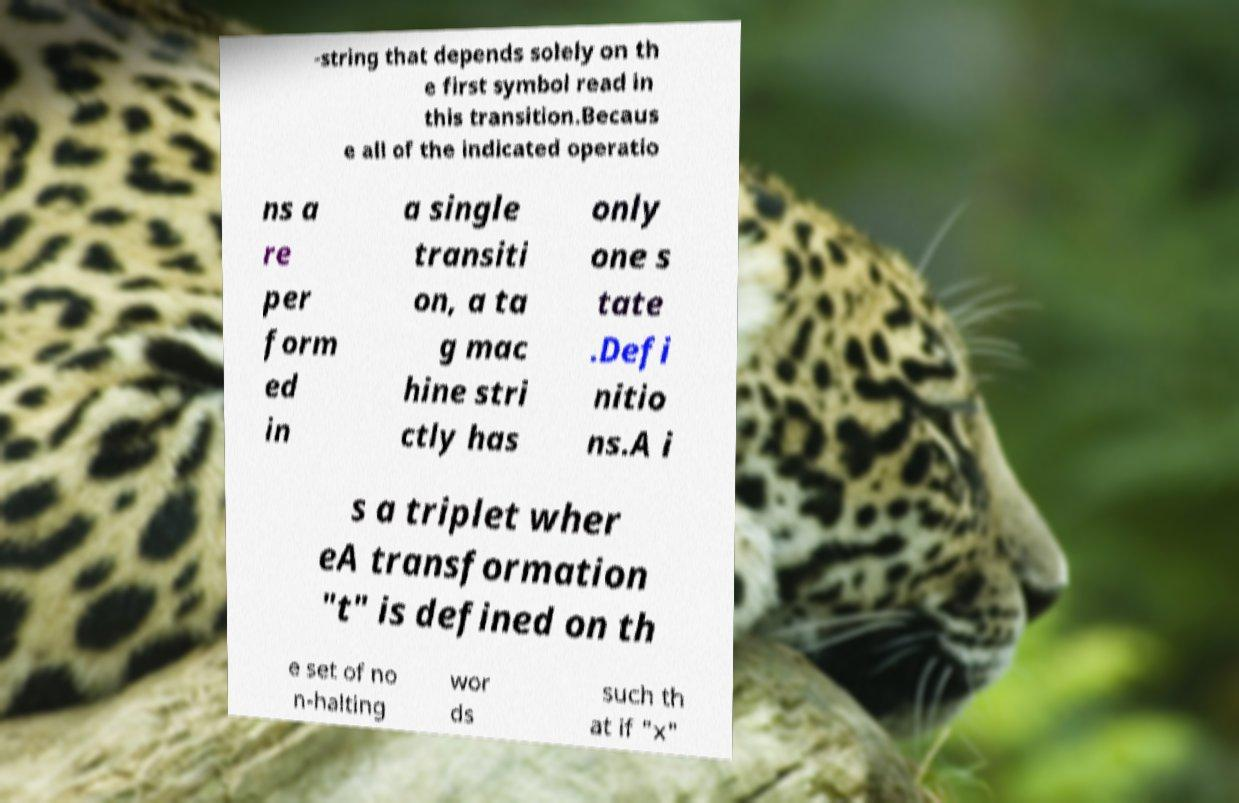Can you accurately transcribe the text from the provided image for me? -string that depends solely on th e first symbol read in this transition.Becaus e all of the indicated operatio ns a re per form ed in a single transiti on, a ta g mac hine stri ctly has only one s tate .Defi nitio ns.A i s a triplet wher eA transformation "t" is defined on th e set of no n-halting wor ds such th at if "x" 